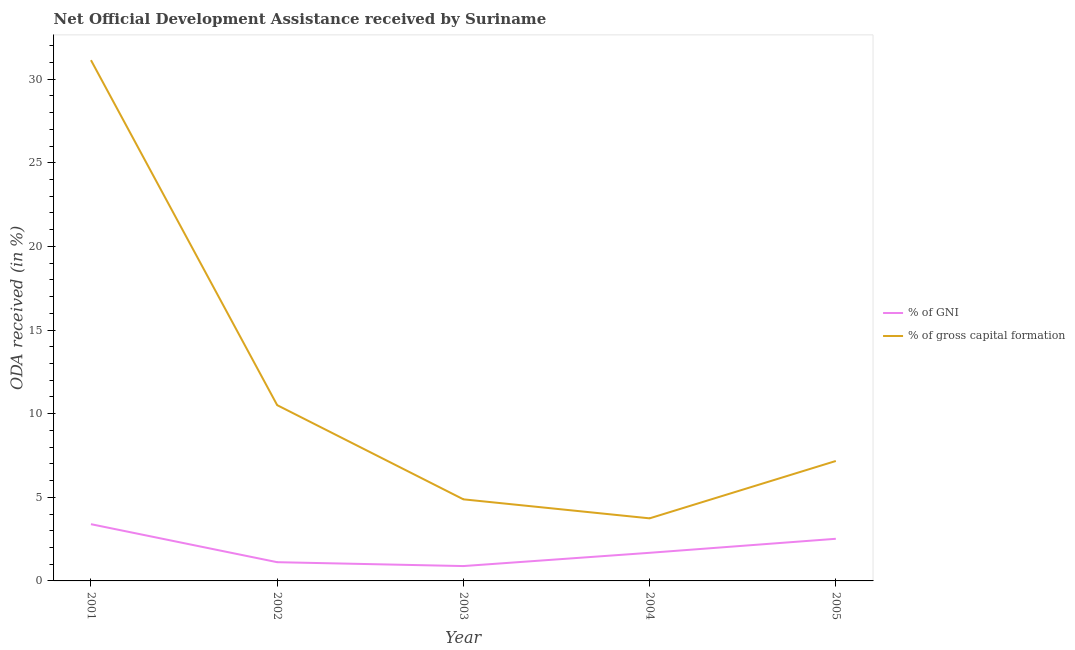Is the number of lines equal to the number of legend labels?
Provide a short and direct response. Yes. What is the oda received as percentage of gni in 2001?
Your answer should be compact. 3.39. Across all years, what is the maximum oda received as percentage of gni?
Give a very brief answer. 3.39. Across all years, what is the minimum oda received as percentage of gross capital formation?
Your answer should be compact. 3.74. What is the total oda received as percentage of gross capital formation in the graph?
Provide a succinct answer. 57.44. What is the difference between the oda received as percentage of gross capital formation in 2003 and that in 2004?
Provide a succinct answer. 1.14. What is the difference between the oda received as percentage of gni in 2004 and the oda received as percentage of gross capital formation in 2001?
Offer a terse response. -29.45. What is the average oda received as percentage of gross capital formation per year?
Keep it short and to the point. 11.49. In the year 2004, what is the difference between the oda received as percentage of gni and oda received as percentage of gross capital formation?
Provide a short and direct response. -2.06. What is the ratio of the oda received as percentage of gni in 2001 to that in 2005?
Keep it short and to the point. 1.35. Is the oda received as percentage of gross capital formation in 2001 less than that in 2003?
Your answer should be very brief. No. Is the difference between the oda received as percentage of gni in 2001 and 2002 greater than the difference between the oda received as percentage of gross capital formation in 2001 and 2002?
Your response must be concise. No. What is the difference between the highest and the second highest oda received as percentage of gross capital formation?
Give a very brief answer. 20.63. What is the difference between the highest and the lowest oda received as percentage of gross capital formation?
Offer a terse response. 27.39. Is the sum of the oda received as percentage of gross capital formation in 2004 and 2005 greater than the maximum oda received as percentage of gni across all years?
Your answer should be compact. Yes. Does the oda received as percentage of gross capital formation monotonically increase over the years?
Offer a terse response. No. How many lines are there?
Ensure brevity in your answer.  2. How many legend labels are there?
Ensure brevity in your answer.  2. What is the title of the graph?
Make the answer very short. Net Official Development Assistance received by Suriname. What is the label or title of the X-axis?
Give a very brief answer. Year. What is the label or title of the Y-axis?
Provide a succinct answer. ODA received (in %). What is the ODA received (in %) of % of GNI in 2001?
Offer a very short reply. 3.39. What is the ODA received (in %) of % of gross capital formation in 2001?
Offer a very short reply. 31.14. What is the ODA received (in %) in % of GNI in 2002?
Offer a terse response. 1.12. What is the ODA received (in %) in % of gross capital formation in 2002?
Make the answer very short. 10.51. What is the ODA received (in %) of % of GNI in 2003?
Give a very brief answer. 0.89. What is the ODA received (in %) of % of gross capital formation in 2003?
Your response must be concise. 4.88. What is the ODA received (in %) of % of GNI in 2004?
Your response must be concise. 1.68. What is the ODA received (in %) of % of gross capital formation in 2004?
Ensure brevity in your answer.  3.74. What is the ODA received (in %) of % of GNI in 2005?
Your response must be concise. 2.52. What is the ODA received (in %) of % of gross capital formation in 2005?
Offer a terse response. 7.17. Across all years, what is the maximum ODA received (in %) in % of GNI?
Keep it short and to the point. 3.39. Across all years, what is the maximum ODA received (in %) of % of gross capital formation?
Ensure brevity in your answer.  31.14. Across all years, what is the minimum ODA received (in %) in % of GNI?
Your answer should be compact. 0.89. Across all years, what is the minimum ODA received (in %) of % of gross capital formation?
Offer a very short reply. 3.74. What is the total ODA received (in %) of % of GNI in the graph?
Make the answer very short. 9.6. What is the total ODA received (in %) of % of gross capital formation in the graph?
Provide a succinct answer. 57.44. What is the difference between the ODA received (in %) of % of GNI in 2001 and that in 2002?
Offer a very short reply. 2.27. What is the difference between the ODA received (in %) of % of gross capital formation in 2001 and that in 2002?
Make the answer very short. 20.63. What is the difference between the ODA received (in %) in % of GNI in 2001 and that in 2003?
Keep it short and to the point. 2.5. What is the difference between the ODA received (in %) in % of gross capital formation in 2001 and that in 2003?
Your response must be concise. 26.26. What is the difference between the ODA received (in %) of % of GNI in 2001 and that in 2004?
Provide a short and direct response. 1.71. What is the difference between the ODA received (in %) of % of gross capital formation in 2001 and that in 2004?
Your answer should be very brief. 27.39. What is the difference between the ODA received (in %) in % of GNI in 2001 and that in 2005?
Give a very brief answer. 0.87. What is the difference between the ODA received (in %) in % of gross capital formation in 2001 and that in 2005?
Offer a terse response. 23.96. What is the difference between the ODA received (in %) of % of GNI in 2002 and that in 2003?
Ensure brevity in your answer.  0.23. What is the difference between the ODA received (in %) of % of gross capital formation in 2002 and that in 2003?
Offer a very short reply. 5.63. What is the difference between the ODA received (in %) of % of GNI in 2002 and that in 2004?
Ensure brevity in your answer.  -0.56. What is the difference between the ODA received (in %) of % of gross capital formation in 2002 and that in 2004?
Provide a short and direct response. 6.77. What is the difference between the ODA received (in %) of % of GNI in 2002 and that in 2005?
Keep it short and to the point. -1.4. What is the difference between the ODA received (in %) of % of gross capital formation in 2002 and that in 2005?
Offer a terse response. 3.34. What is the difference between the ODA received (in %) of % of GNI in 2003 and that in 2004?
Offer a very short reply. -0.79. What is the difference between the ODA received (in %) of % of gross capital formation in 2003 and that in 2004?
Make the answer very short. 1.14. What is the difference between the ODA received (in %) in % of GNI in 2003 and that in 2005?
Give a very brief answer. -1.63. What is the difference between the ODA received (in %) of % of gross capital formation in 2003 and that in 2005?
Keep it short and to the point. -2.29. What is the difference between the ODA received (in %) in % of GNI in 2004 and that in 2005?
Ensure brevity in your answer.  -0.84. What is the difference between the ODA received (in %) of % of gross capital formation in 2004 and that in 2005?
Give a very brief answer. -3.43. What is the difference between the ODA received (in %) in % of GNI in 2001 and the ODA received (in %) in % of gross capital formation in 2002?
Offer a terse response. -7.12. What is the difference between the ODA received (in %) in % of GNI in 2001 and the ODA received (in %) in % of gross capital formation in 2003?
Your answer should be very brief. -1.48. What is the difference between the ODA received (in %) in % of GNI in 2001 and the ODA received (in %) in % of gross capital formation in 2004?
Make the answer very short. -0.35. What is the difference between the ODA received (in %) in % of GNI in 2001 and the ODA received (in %) in % of gross capital formation in 2005?
Provide a succinct answer. -3.78. What is the difference between the ODA received (in %) of % of GNI in 2002 and the ODA received (in %) of % of gross capital formation in 2003?
Provide a succinct answer. -3.76. What is the difference between the ODA received (in %) of % of GNI in 2002 and the ODA received (in %) of % of gross capital formation in 2004?
Your response must be concise. -2.62. What is the difference between the ODA received (in %) of % of GNI in 2002 and the ODA received (in %) of % of gross capital formation in 2005?
Provide a succinct answer. -6.05. What is the difference between the ODA received (in %) of % of GNI in 2003 and the ODA received (in %) of % of gross capital formation in 2004?
Offer a terse response. -2.85. What is the difference between the ODA received (in %) in % of GNI in 2003 and the ODA received (in %) in % of gross capital formation in 2005?
Offer a very short reply. -6.28. What is the difference between the ODA received (in %) of % of GNI in 2004 and the ODA received (in %) of % of gross capital formation in 2005?
Your answer should be compact. -5.49. What is the average ODA received (in %) of % of GNI per year?
Ensure brevity in your answer.  1.92. What is the average ODA received (in %) in % of gross capital formation per year?
Provide a short and direct response. 11.49. In the year 2001, what is the difference between the ODA received (in %) of % of GNI and ODA received (in %) of % of gross capital formation?
Your answer should be compact. -27.74. In the year 2002, what is the difference between the ODA received (in %) in % of GNI and ODA received (in %) in % of gross capital formation?
Ensure brevity in your answer.  -9.39. In the year 2003, what is the difference between the ODA received (in %) of % of GNI and ODA received (in %) of % of gross capital formation?
Give a very brief answer. -3.99. In the year 2004, what is the difference between the ODA received (in %) in % of GNI and ODA received (in %) in % of gross capital formation?
Your answer should be compact. -2.06. In the year 2005, what is the difference between the ODA received (in %) of % of GNI and ODA received (in %) of % of gross capital formation?
Give a very brief answer. -4.65. What is the ratio of the ODA received (in %) of % of GNI in 2001 to that in 2002?
Your answer should be compact. 3.03. What is the ratio of the ODA received (in %) of % of gross capital formation in 2001 to that in 2002?
Offer a very short reply. 2.96. What is the ratio of the ODA received (in %) of % of GNI in 2001 to that in 2003?
Provide a succinct answer. 3.82. What is the ratio of the ODA received (in %) in % of gross capital formation in 2001 to that in 2003?
Ensure brevity in your answer.  6.38. What is the ratio of the ODA received (in %) of % of GNI in 2001 to that in 2004?
Your answer should be very brief. 2.02. What is the ratio of the ODA received (in %) of % of gross capital formation in 2001 to that in 2004?
Your answer should be compact. 8.32. What is the ratio of the ODA received (in %) in % of GNI in 2001 to that in 2005?
Your answer should be compact. 1.35. What is the ratio of the ODA received (in %) in % of gross capital formation in 2001 to that in 2005?
Provide a succinct answer. 4.34. What is the ratio of the ODA received (in %) of % of GNI in 2002 to that in 2003?
Give a very brief answer. 1.26. What is the ratio of the ODA received (in %) in % of gross capital formation in 2002 to that in 2003?
Offer a very short reply. 2.15. What is the ratio of the ODA received (in %) in % of GNI in 2002 to that in 2004?
Give a very brief answer. 0.67. What is the ratio of the ODA received (in %) in % of gross capital formation in 2002 to that in 2004?
Provide a succinct answer. 2.81. What is the ratio of the ODA received (in %) in % of GNI in 2002 to that in 2005?
Offer a terse response. 0.44. What is the ratio of the ODA received (in %) in % of gross capital formation in 2002 to that in 2005?
Provide a short and direct response. 1.47. What is the ratio of the ODA received (in %) of % of GNI in 2003 to that in 2004?
Give a very brief answer. 0.53. What is the ratio of the ODA received (in %) in % of gross capital formation in 2003 to that in 2004?
Your answer should be compact. 1.3. What is the ratio of the ODA received (in %) of % of GNI in 2003 to that in 2005?
Offer a very short reply. 0.35. What is the ratio of the ODA received (in %) of % of gross capital formation in 2003 to that in 2005?
Provide a succinct answer. 0.68. What is the ratio of the ODA received (in %) of % of GNI in 2004 to that in 2005?
Ensure brevity in your answer.  0.67. What is the ratio of the ODA received (in %) of % of gross capital formation in 2004 to that in 2005?
Your answer should be very brief. 0.52. What is the difference between the highest and the second highest ODA received (in %) of % of GNI?
Provide a short and direct response. 0.87. What is the difference between the highest and the second highest ODA received (in %) of % of gross capital formation?
Your response must be concise. 20.63. What is the difference between the highest and the lowest ODA received (in %) of % of GNI?
Your answer should be very brief. 2.5. What is the difference between the highest and the lowest ODA received (in %) of % of gross capital formation?
Your answer should be very brief. 27.39. 